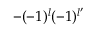Convert formula to latex. <formula><loc_0><loc_0><loc_500><loc_500>- ( - 1 ) ^ { l } ( - 1 ) ^ { l ^ { \prime } }</formula> 